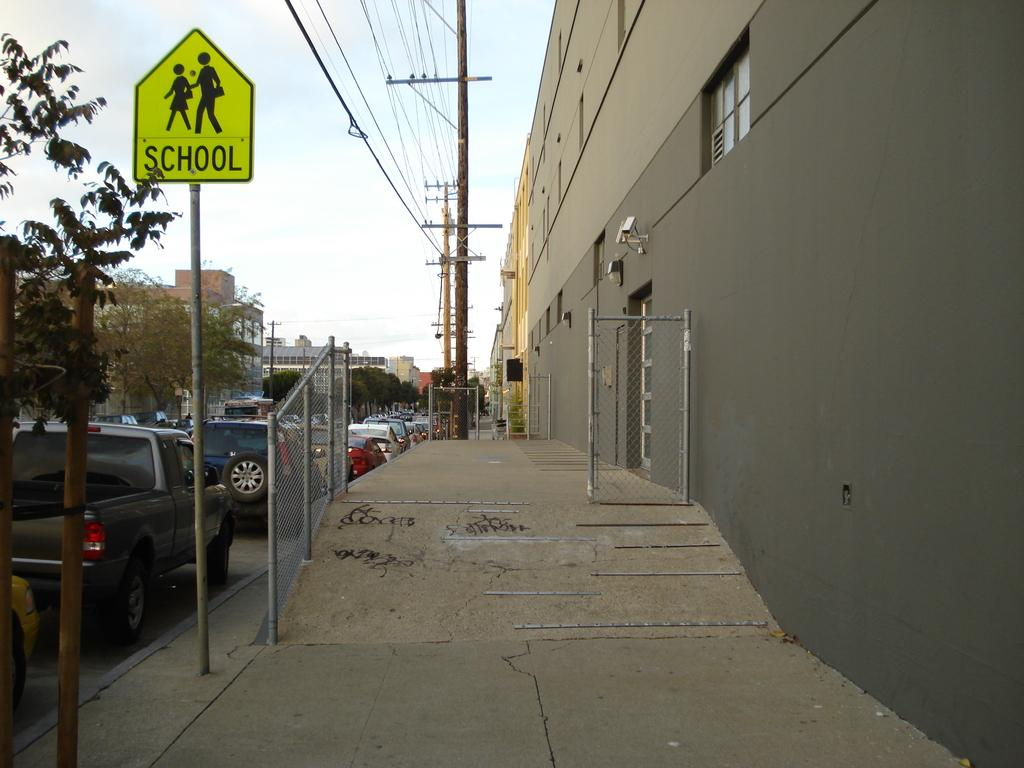<image>
Create a compact narrative representing the image presented. A city sidewalk with a school crossing sign on the left. 